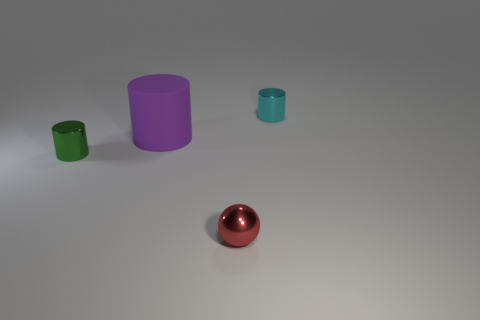Are there any other things that have the same size as the matte thing?
Keep it short and to the point. No. The object to the right of the sphere has what shape?
Your response must be concise. Cylinder. There is a tiny metallic object that is behind the small metallic cylinder in front of the cyan metal thing; what is its color?
Offer a terse response. Cyan. What color is the matte thing that is the same shape as the cyan shiny thing?
Ensure brevity in your answer.  Purple. Does the tiny sphere have the same color as the cylinder that is behind the purple cylinder?
Offer a very short reply. No. What is the shape of the small metal object that is both behind the small metallic ball and in front of the large thing?
Ensure brevity in your answer.  Cylinder. The tiny cylinder left of the metal cylinder behind the metal cylinder that is in front of the purple thing is made of what material?
Offer a terse response. Metal. Are there more small objects behind the small cyan metal object than balls behind the purple rubber cylinder?
Your answer should be compact. No. How many large things have the same material as the cyan cylinder?
Offer a very short reply. 0. There is a small object that is on the left side of the red sphere; is it the same shape as the object that is behind the purple thing?
Your answer should be very brief. Yes. 